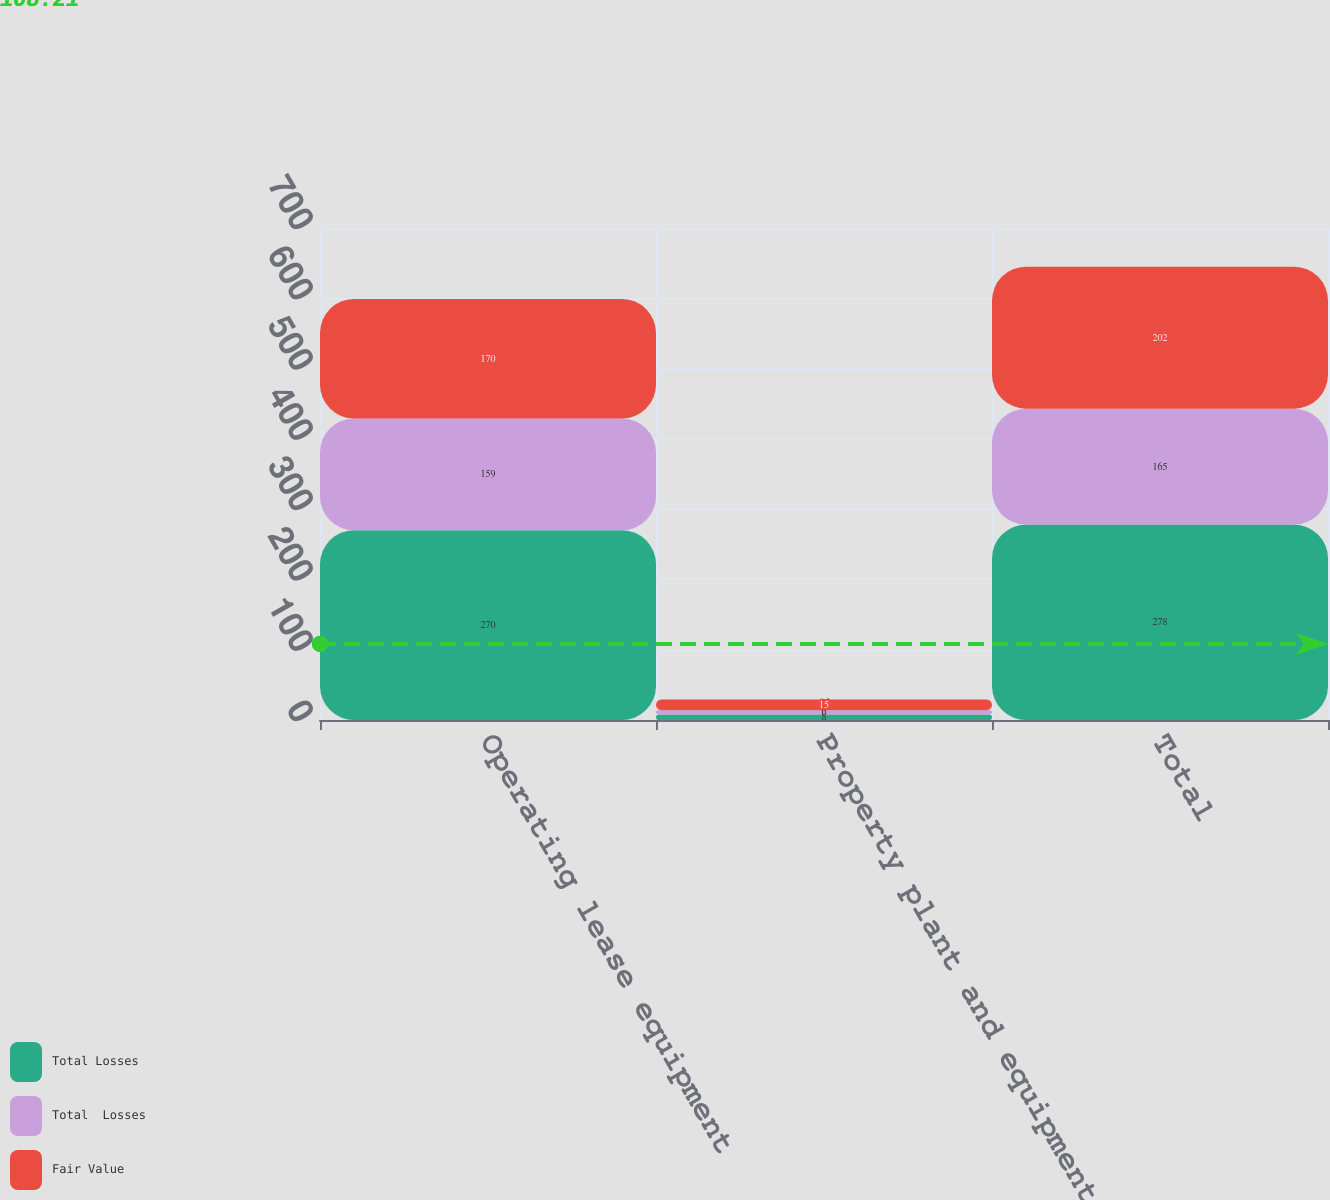Convert chart. <chart><loc_0><loc_0><loc_500><loc_500><stacked_bar_chart><ecel><fcel>Operating lease equipment<fcel>Property plant and equipment<fcel>Total<nl><fcel>Total Losses<fcel>270<fcel>8<fcel>278<nl><fcel>Total  Losses<fcel>159<fcel>6<fcel>165<nl><fcel>Fair Value<fcel>170<fcel>15<fcel>202<nl></chart> 